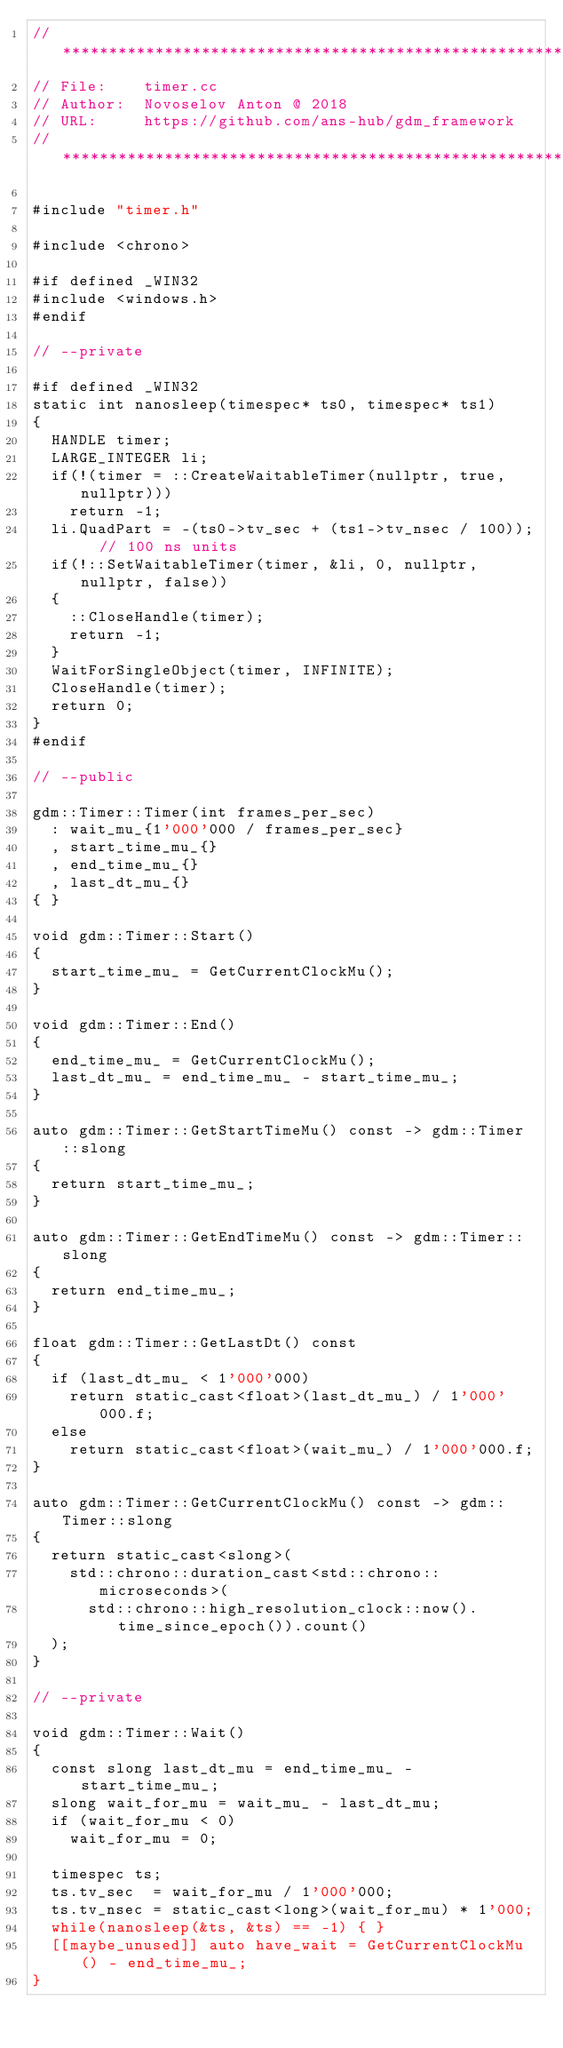<code> <loc_0><loc_0><loc_500><loc_500><_C++_>// *************************************************************
// File:    timer.cc
// Author:  Novoselov Anton @ 2018
// URL:     https://github.com/ans-hub/gdm_framework
// *************************************************************

#include "timer.h"

#include <chrono>

#if defined _WIN32
#include <windows.h>
#endif

// --private

#if defined _WIN32
static int nanosleep(timespec* ts0, timespec* ts1)
{
  HANDLE timer;
  LARGE_INTEGER li;
  if(!(timer = ::CreateWaitableTimer(nullptr, true, nullptr)))
	  return -1;
  li.QuadPart = -(ts0->tv_sec + (ts1->tv_nsec / 100));  // 100 ns units
  if(!::SetWaitableTimer(timer, &li, 0, nullptr, nullptr, false))
  {
		::CloseHandle(timer);
	  return -1;
	}
  WaitForSingleObject(timer, INFINITE);
  CloseHandle(timer);
  return 0;
}
#endif

// --public

gdm::Timer::Timer(int frames_per_sec)
  : wait_mu_{1'000'000 / frames_per_sec}
  , start_time_mu_{}
  , end_time_mu_{}
  , last_dt_mu_{}
{ }

void gdm::Timer::Start()
{
  start_time_mu_ = GetCurrentClockMu();
}

void gdm::Timer::End()
{
  end_time_mu_ = GetCurrentClockMu();
  last_dt_mu_ = end_time_mu_ - start_time_mu_;
}

auto gdm::Timer::GetStartTimeMu() const -> gdm::Timer::slong
{
  return start_time_mu_;
}

auto gdm::Timer::GetEndTimeMu() const -> gdm::Timer::slong
{
  return end_time_mu_;
}

float gdm::Timer::GetLastDt() const
{
  if (last_dt_mu_ < 1'000'000)
    return static_cast<float>(last_dt_mu_) / 1'000'000.f;
  else
    return static_cast<float>(wait_mu_) / 1'000'000.f;
}

auto gdm::Timer::GetCurrentClockMu() const -> gdm::Timer::slong
{
  return static_cast<slong>(
    std::chrono::duration_cast<std::chrono::microseconds>(
      std::chrono::high_resolution_clock::now().time_since_epoch()).count()
  );
}

// --private

void gdm::Timer::Wait()
{
  const slong last_dt_mu = end_time_mu_ - start_time_mu_;
  slong wait_for_mu = wait_mu_ - last_dt_mu;
  if (wait_for_mu < 0)
    wait_for_mu = 0;

  timespec ts;
  ts.tv_sec  = wait_for_mu / 1'000'000;
  ts.tv_nsec = static_cast<long>(wait_for_mu) * 1'000;
  while(nanosleep(&ts, &ts) == -1) { }
  [[maybe_unused]] auto have_wait = GetCurrentClockMu() - end_time_mu_;
}
</code> 